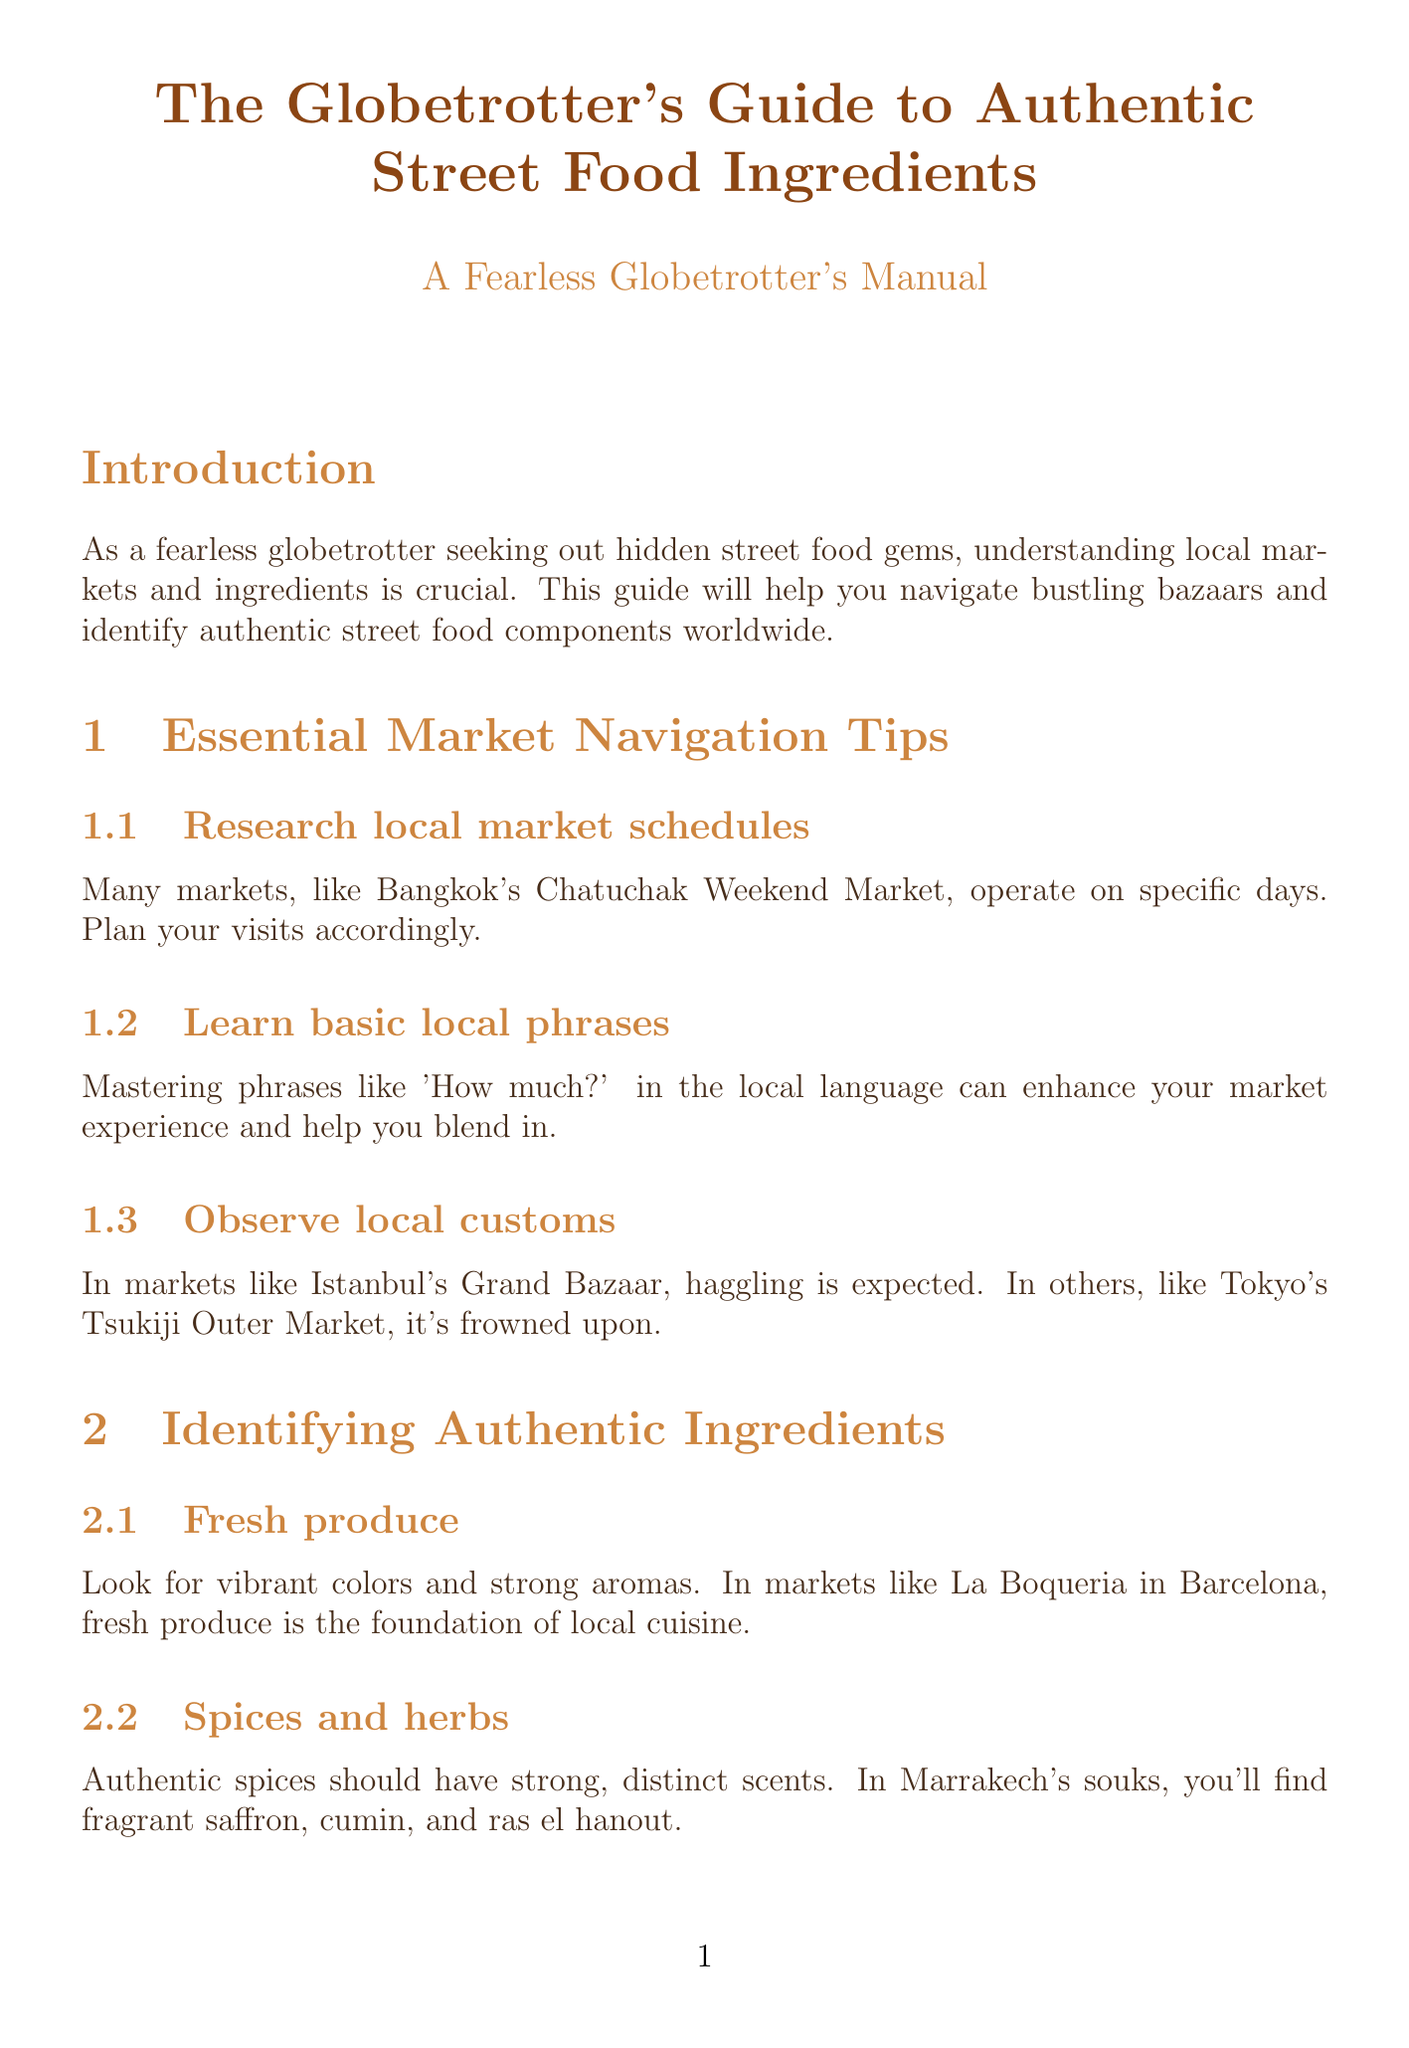What is the title of the guide? The title of the guide is found in the document's header.
Answer: The Globetrotter's Guide to Authentic Street Food Ingredients Which market is mentioned for its specific operating days? The document specifies a market known for its schedule in the relevant section.
Answer: Chatuchak Weekend Market What vibrant colors indicate in markets? The document describes the significance of colors in a specific subsection about ingredients.
Answer: Fresh produce Which Middle Eastern market is highlighted for unique spices? The document references a market that stands out in the Middle East section.
Answer: Carmel Market What is an essential practice to ensure food safety? The document lists practices to maintain food safety in a dedicated section.
Answer: Observe hygiene practices What ingredient is commonly found in Southeast Asian markets? The guide provides a list of ingredients specific to the Southeast Asia section.
Answer: Lemongrass How should fresh meat and seafood smell? The text outlines the expected quality regarding odors in the relevant subsection.
Answer: Strong odor What preparation method is common worldwide? The document hints at a universally recognized cooking technique in the preparation section.
Answer: Grilling 